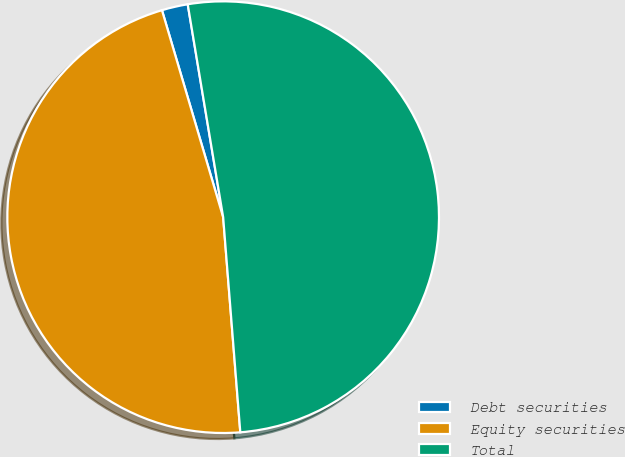<chart> <loc_0><loc_0><loc_500><loc_500><pie_chart><fcel>Debt securities<fcel>Equity securities<fcel>Total<nl><fcel>1.95%<fcel>46.69%<fcel>51.36%<nl></chart> 